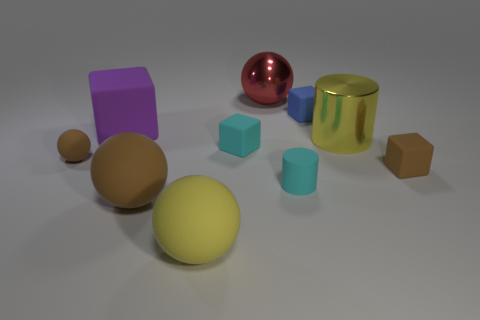Can you describe the largest object in the image? The largest object in this image appears to be the yellow sphere. It has a smooth matte surface and resides centrally among the other objects, suggesting it might be a focal point in this collection. 